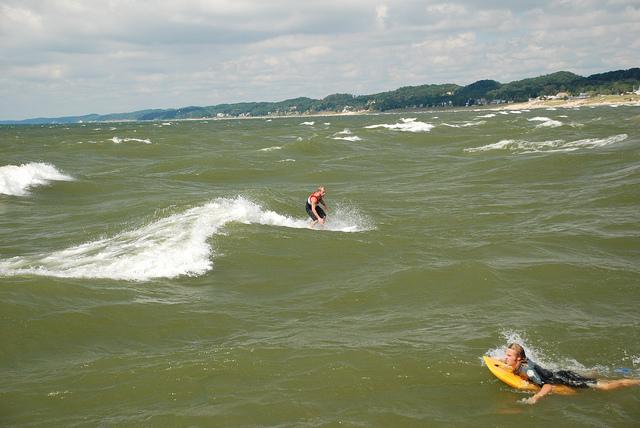What color is the water?
Answer briefly. Green. Is the water blue?
Give a very brief answer. No. How many surfers do you see?
Answer briefly. 2. How many surfers are there?
Answer briefly. 2. What color is the surfboard?
Give a very brief answer. Yellow. 